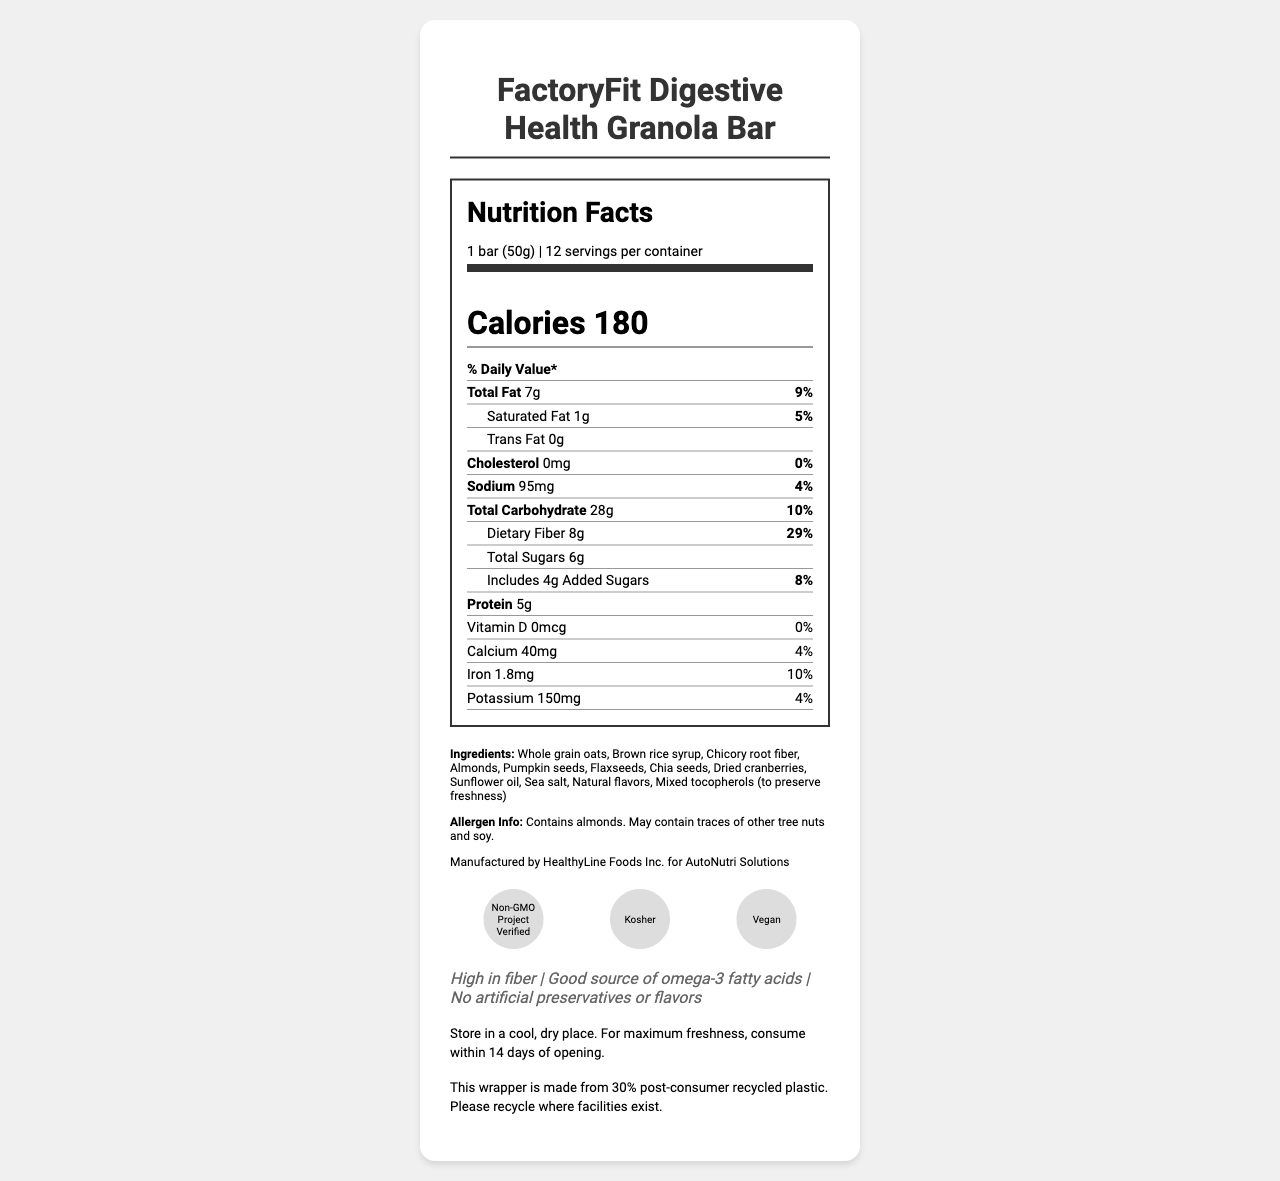what is the serving size of the FactoryFit Digestive Health Granola Bar? The serving size is mentioned at the beginning of the nutrition facts as "1 bar (50g)".
Answer: 1 bar (50g) how much dietary fiber does each granola bar contain? The dietary fiber content is explicitly stated as "Dietary Fiber 8g".
Answer: 8g what are the main sources of fat listed in the ingredients? The ingredients that are likely sources of fat are almonds, pumpkin seeds, flaxseeds, chia seeds, and sunflower oil.
Answer: Almonds, Pumpkin seeds, Flaxseeds, Chia seeds, Sunflower oil what certification does this product have? The product is certified as Non-GMO Project Verified, Kosher, and Vegan, as shown by the certification icons in the document.
Answer: Non-GMO Project Verified, Kosher, Vegan how many calories does one serving of the granola bar provide? The document states the calories per serving as 180.
Answer: 180 calories which nutrient is present in the highest daily value percentage in the granola bar? A. Saturated Fat B. Dietary Fiber C. Iron D. Sodium Dietary Fiber has the highest daily value percentage at 29%.
Answer: B. Dietary Fiber according to the document, how should the granola bars be stored? The storage instructions are given at the end of the document, stating to store in a cool, dry place, and to consume within 14 days of opening.
Answer: Store in a cool, dry place. For maximum freshness, consume within 14 days of opening. what percentage of the daily value for protein does the granola bar provide? A. 4% B. 5% C. 7% D. 10% The granola bar provides 5g of protein, and while the daily value percentage is not explicitly stated, it provides 5g out of the recommended daily allowance.
Answer: B. 5% are there any artificial preservatives or flavors in the granola bar? The claim statements indicate that there are no artificial preservatives or flavors.
Answer: No is the granola bar suitable for someone with a nut allergy? The document states that the product contains almonds and may contain traces of other tree nuts and soy, indicating it is not suitable for someone with a nut allergy.
Answer: No what is the main claim of the FactoryFit Digestive Health Granola Bar? The main claim is that it is high in fiber, as stated under the claim statements.
Answer: High in fiber how much iron does one serving of the granola bar contain? The document states that each serving contains 1.8mg of iron.
Answer: 1.8mg who manufactures the FactoryFit Digestive Health Granola Bar? The manufacturer information states it is produced by HealthyLine Foods Inc. for AutoNutri Solutions.
Answer: HealthyLine Foods Inc. for AutoNutri Solutions what is the price of the granola bar? The document does not provide any information regarding the price of the granola bar.
Answer: Cannot be determined 